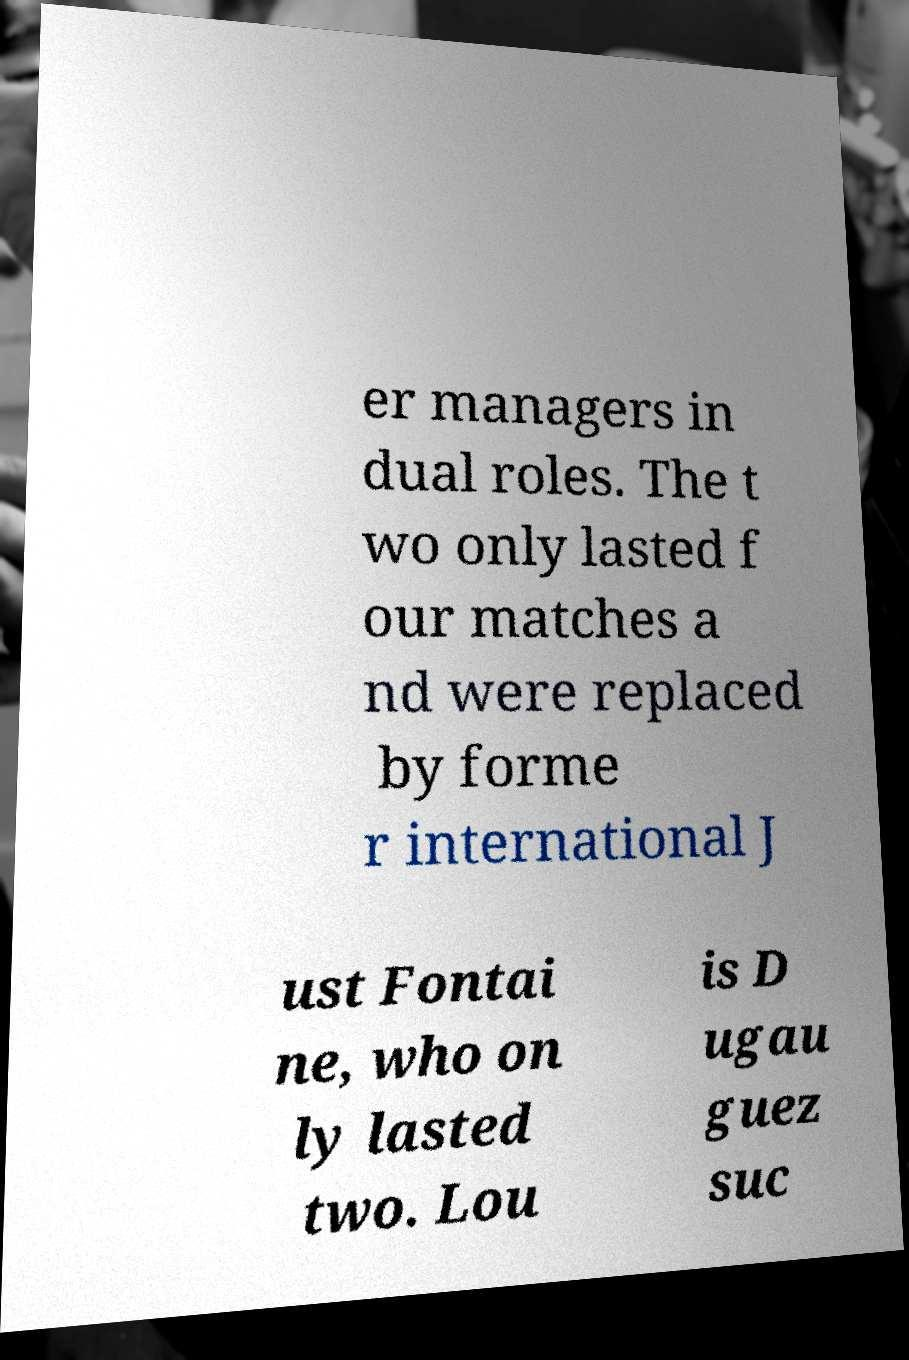I need the written content from this picture converted into text. Can you do that? er managers in dual roles. The t wo only lasted f our matches a nd were replaced by forme r international J ust Fontai ne, who on ly lasted two. Lou is D ugau guez suc 